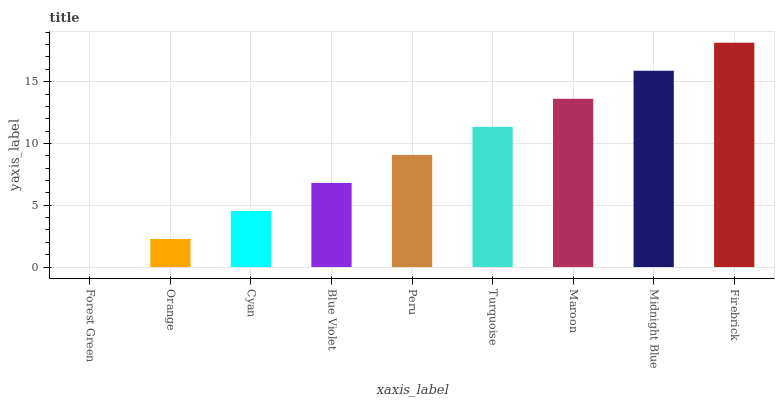Is Forest Green the minimum?
Answer yes or no. Yes. Is Firebrick the maximum?
Answer yes or no. Yes. Is Orange the minimum?
Answer yes or no. No. Is Orange the maximum?
Answer yes or no. No. Is Orange greater than Forest Green?
Answer yes or no. Yes. Is Forest Green less than Orange?
Answer yes or no. Yes. Is Forest Green greater than Orange?
Answer yes or no. No. Is Orange less than Forest Green?
Answer yes or no. No. Is Peru the high median?
Answer yes or no. Yes. Is Peru the low median?
Answer yes or no. Yes. Is Firebrick the high median?
Answer yes or no. No. Is Maroon the low median?
Answer yes or no. No. 